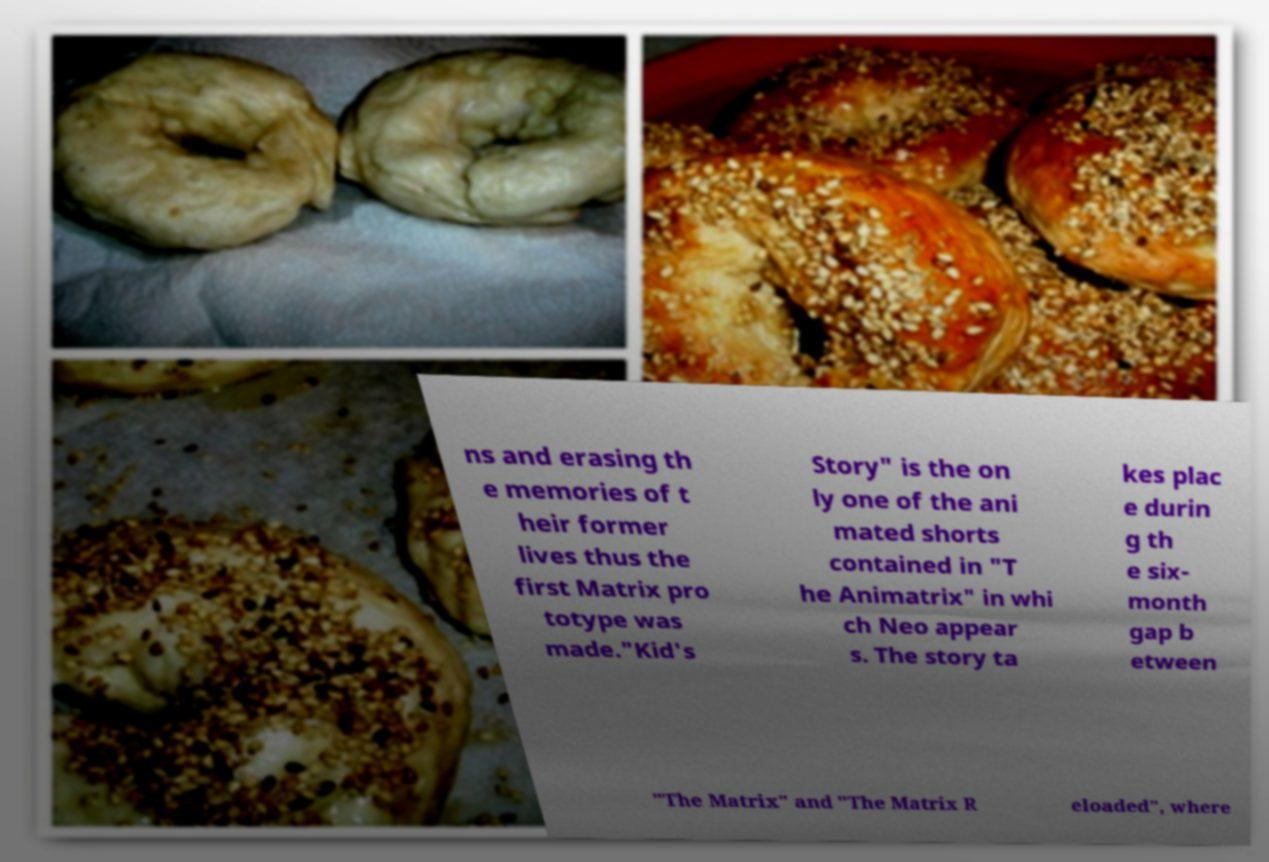I need the written content from this picture converted into text. Can you do that? ns and erasing th e memories of t heir former lives thus the first Matrix pro totype was made."Kid's Story" is the on ly one of the ani mated shorts contained in "T he Animatrix" in whi ch Neo appear s. The story ta kes plac e durin g th e six- month gap b etween "The Matrix" and "The Matrix R eloaded", where 